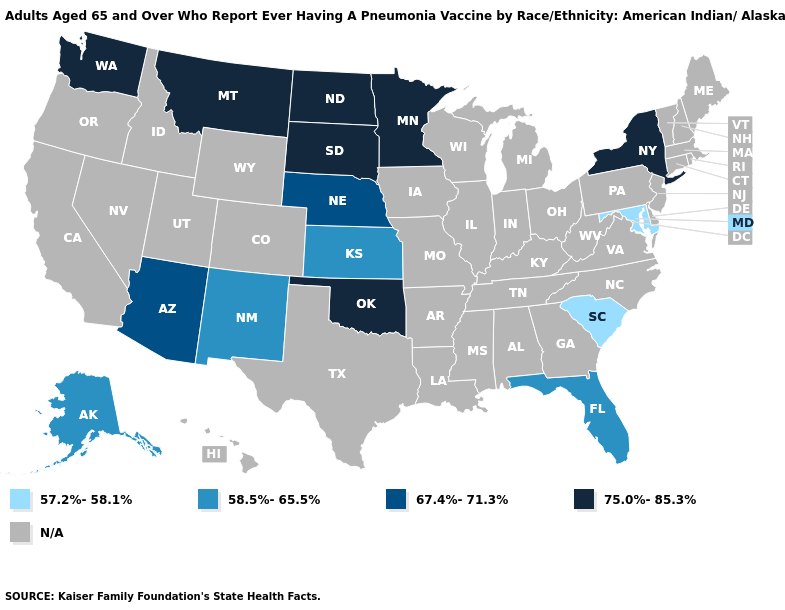What is the value of Nevada?
Short answer required. N/A. Which states have the lowest value in the MidWest?
Short answer required. Kansas. What is the lowest value in the USA?
Keep it brief. 57.2%-58.1%. Name the states that have a value in the range 75.0%-85.3%?
Write a very short answer. Minnesota, Montana, New York, North Dakota, Oklahoma, South Dakota, Washington. Does the first symbol in the legend represent the smallest category?
Answer briefly. Yes. Name the states that have a value in the range 75.0%-85.3%?
Short answer required. Minnesota, Montana, New York, North Dakota, Oklahoma, South Dakota, Washington. Which states have the lowest value in the Northeast?
Quick response, please. New York. What is the value of Utah?
Keep it brief. N/A. What is the lowest value in the MidWest?
Keep it brief. 58.5%-65.5%. Which states hav the highest value in the South?
Quick response, please. Oklahoma. Does New Mexico have the highest value in the West?
Quick response, please. No. 